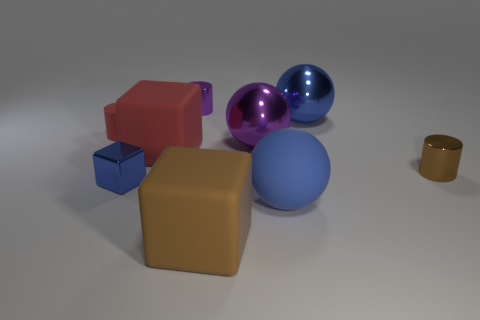Subtract all matte blocks. How many blocks are left? 1 Add 1 metallic cylinders. How many objects exist? 10 Subtract all blue spheres. How many spheres are left? 1 Subtract all balls. How many objects are left? 6 Add 6 tiny green shiny cylinders. How many tiny green shiny cylinders exist? 6 Subtract 0 cyan spheres. How many objects are left? 9 Subtract 3 cubes. How many cubes are left? 0 Subtract all purple spheres. Subtract all purple cubes. How many spheres are left? 2 Subtract all brown blocks. How many purple spheres are left? 1 Subtract all large blue matte spheres. Subtract all purple metallic objects. How many objects are left? 6 